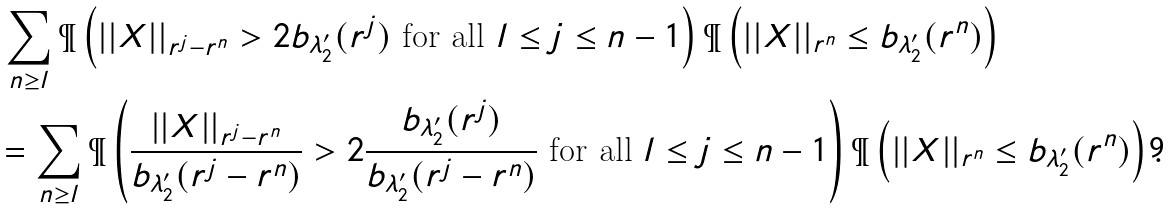<formula> <loc_0><loc_0><loc_500><loc_500>& \, \sum _ { n \geq l } \P \left ( | | X | | _ { r ^ { j } - r ^ { n } } > 2 b _ { \lambda _ { 2 } ^ { \prime } } ( r ^ { j } ) \text { for all $l\leq j\leq n-1$} \right ) \P \left ( | | X | | _ { r ^ { n } } \leq b _ { \lambda _ { 2 } ^ { \prime } } ( r ^ { n } ) \right ) \\ & = \sum _ { n \geq l } \P \left ( \frac { | | X | | _ { r ^ { j } - r ^ { n } } } { b _ { \lambda _ { 2 } ^ { \prime } } ( r ^ { j } - r ^ { n } ) } > 2 \frac { b _ { \lambda _ { 2 } ^ { \prime } } ( r ^ { j } ) } { b _ { \lambda _ { 2 } ^ { \prime } } ( r ^ { j } - r ^ { n } ) } \text { for all $l\leq j\leq n-1$} \right ) \P \left ( | | X | | _ { r ^ { n } } \leq b _ { \lambda _ { 2 } ^ { \prime } } ( r ^ { n } ) \right ) .</formula> 